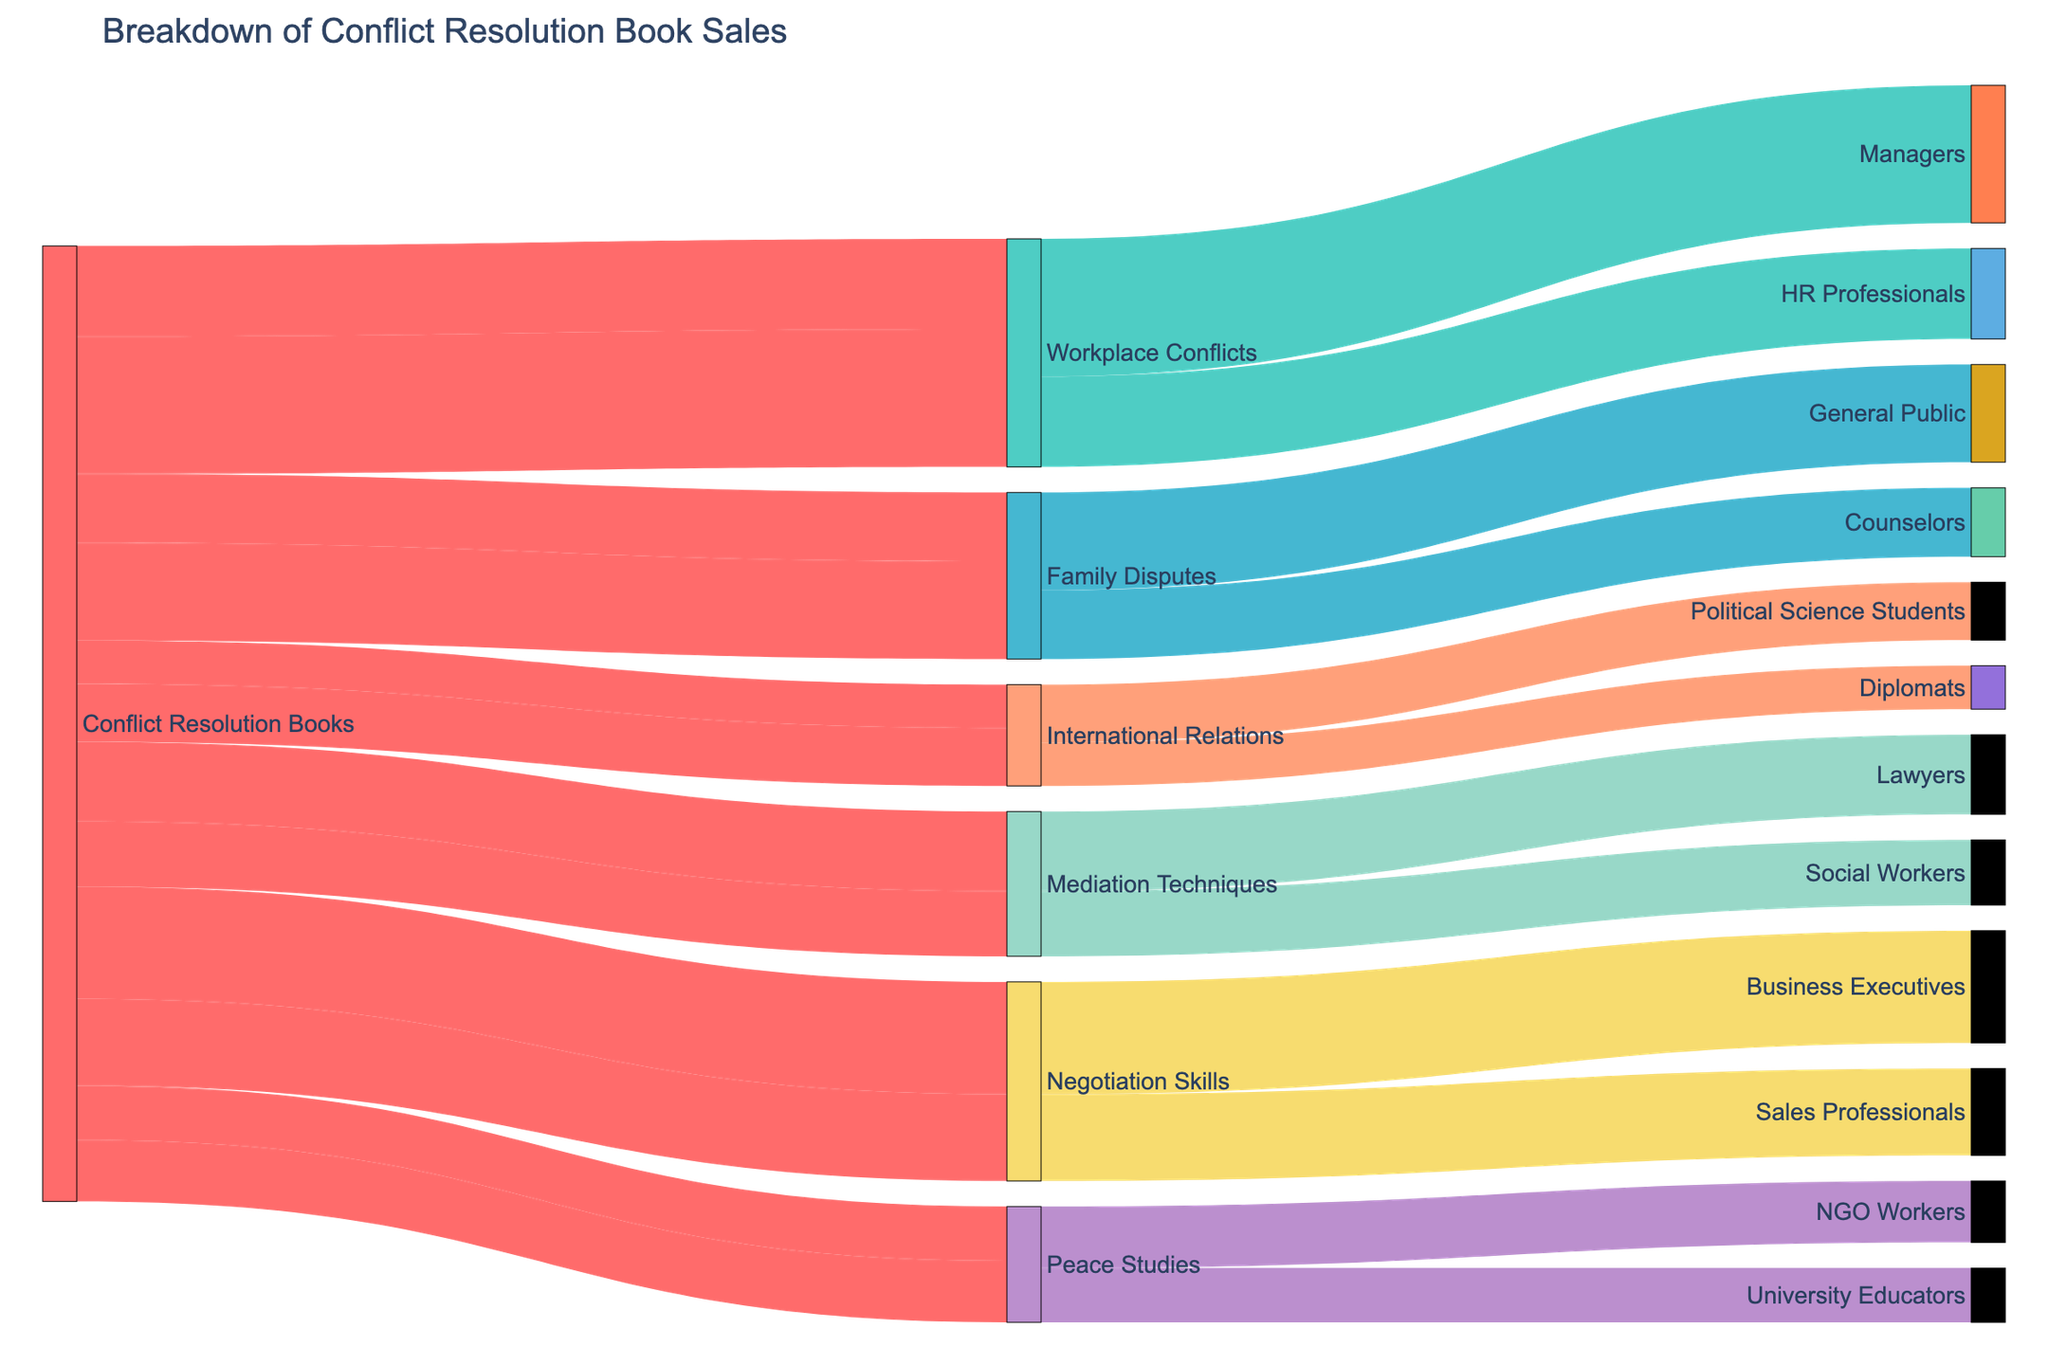What is the title of the Sankey Diagram? The title is typically found at the top of the diagram and it provides a summary of what the diagram represents. The title in this case is "Breakdown of Conflict Resolution Book Sales".
Answer: Breakdown of Conflict Resolution Book Sales How many subject matters are represented in the diagram? The subject matters are the intermediate nodes between "Conflict Resolution Books" and the target audiences. They are: Workplace Conflicts, Family Disputes, International Relations, Mediation Techniques, Negotiation Skills, and Peace Studies. Counting these, there are six subject matters.
Answer: Six Which target audience has the highest sales figure? Look for the thickest link connecting to a target audience node. The target audience with the highest sales figure is Managers with 3800 sales.
Answer: Managers What is the total number of sales for "Family Disputes" books? Sum up the sales figures for each target audience under "Family Disputes". That is, 1900 for Counselors and 2700 for General Public, which gives a total of 1900 + 2700 = 4600.
Answer: 4600 Which subject matter has the lowest sales to HR Professionals? Identify which link from "Conflict Resolution Books" to "HR Professionals" has the smallest thickness. Since only "Workplace Conflicts" has a link to HR Professionals with 2500 sales, it is implicitly the lowest within its category.
Answer: Workplace Conflicts How do the sales for "Negotiation Skills" compare between Business Executives and Sales Professionals? Compare the two sales figures. "Negotiation Skills" has 3100 sales for Business Executives and 2400 for Sales Professionals. Business Executives have higher sales by 3100 - 2400 = 700.
Answer: Business Executives have 700 more sales than Sales Professionals Calculate the average sales per subject matter for "Mediation Techniques". Sum the sales figures for all target audiences under "Mediation Techniques" and divide by the number of target audiences. For Mediation Techniques, the sales are 2200 for Lawyers and 1800 for Social Workers. The average is (2200 + 1800) / 2 = 2000.
Answer: 2000 What is the proportion of sales for "International Relations" books targeting Diplomats compared to Political Science Students? Divide the sales figure for Diplomats by the sales figure for Political Science Students and multiply by 100 to express it as a percentage. The sales to Diplomats are 1200, and to Political Science Students are 1600. The proportion is (1200 / 1600) * 100 = 75%.
Answer: 75% Which group of target audiences has the highest combined sales? Sum the sales figures for all target audiences and compare the totals. HR Professionals: 2500, Managers: 3800, Counselors: 1900, General Public: 2700, Diplomats: 1200, Political Science Students: 1600, Lawyers: 2200, Social Workers: 1800, Business Executives: 3100, Sales Professionals: 2400, University Educators: 1500, NGO Workers: 1700. The calculation reveals that Managers have the highest individual sales figure of 3800.
Answer: Managers Identify the subject matter that contributes the least to the "General Public". Track the link from "General Public" to the corresponding subject matter node. The "General Public" category is linked only under "Family Disputes" with 2700 sales. By default, "Family Disputes" is the least contributor within that category.
Answer: Family Disputes 